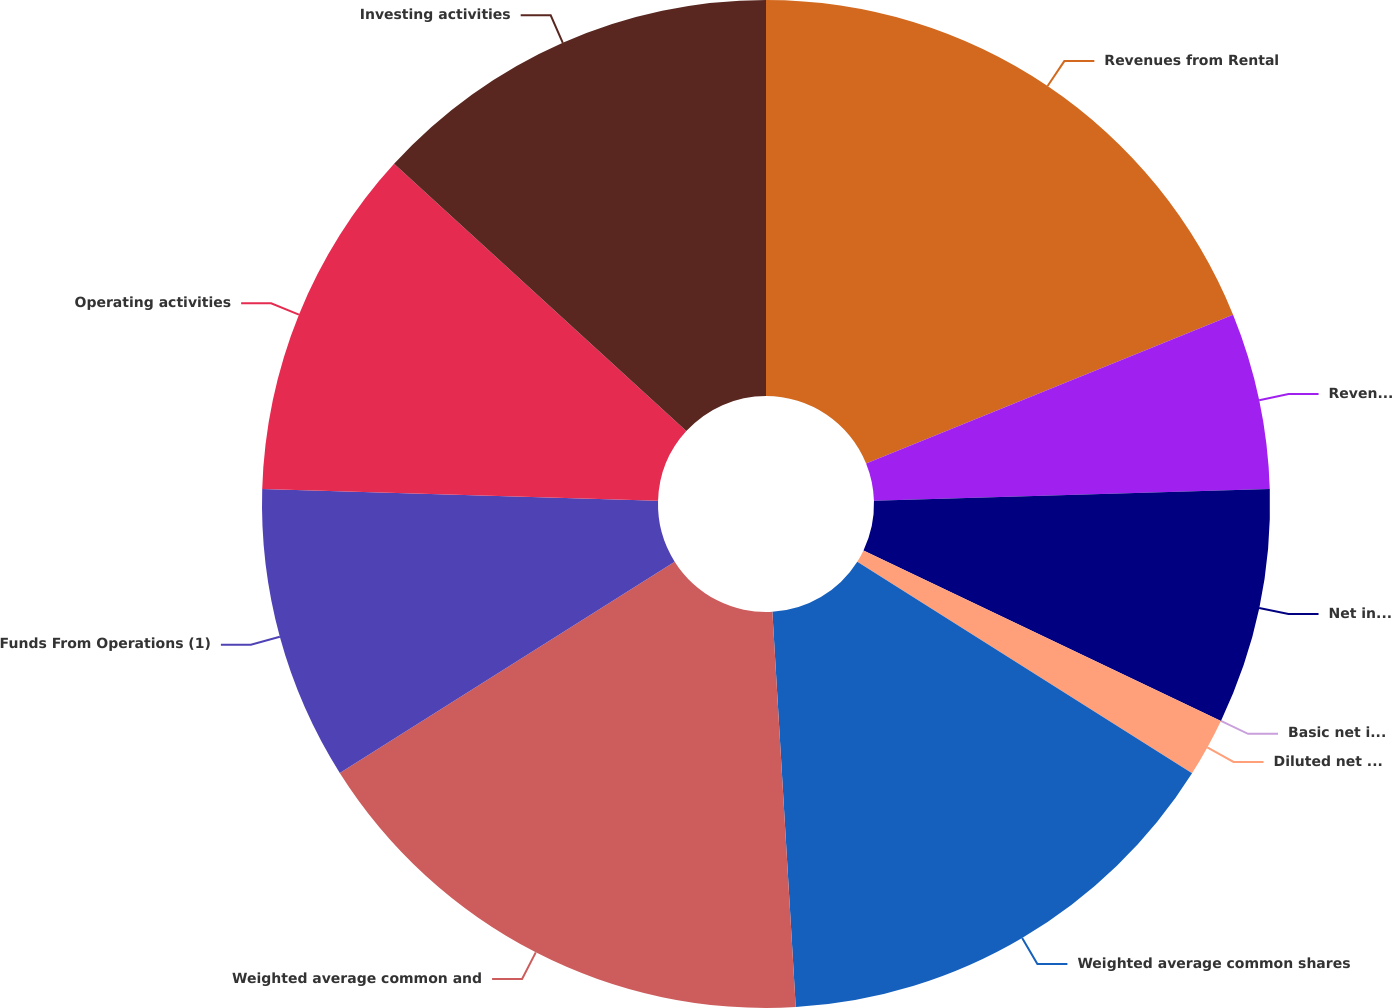Convert chart. <chart><loc_0><loc_0><loc_500><loc_500><pie_chart><fcel>Revenues from Rental<fcel>Revenues from Service<fcel>Net income available for<fcel>Basic net income per share<fcel>Diluted net income per share<fcel>Weighted average common shares<fcel>Weighted average common and<fcel>Funds From Operations (1)<fcel>Operating activities<fcel>Investing activities<nl><fcel>18.87%<fcel>5.66%<fcel>7.55%<fcel>0.0%<fcel>1.89%<fcel>15.09%<fcel>16.98%<fcel>9.43%<fcel>11.32%<fcel>13.21%<nl></chart> 